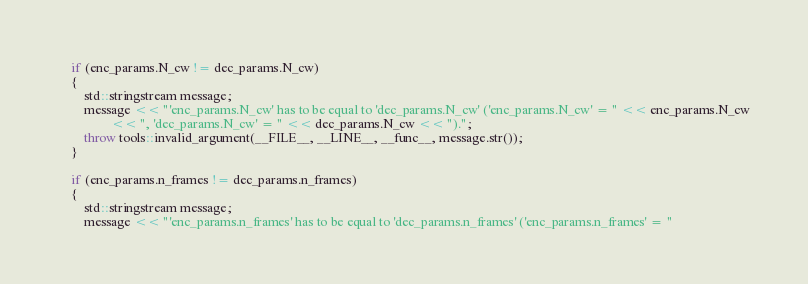<code> <loc_0><loc_0><loc_500><loc_500><_C++_>
	if (enc_params.N_cw != dec_params.N_cw)
	{
		std::stringstream message;
		message << "'enc_params.N_cw' has to be equal to 'dec_params.N_cw' ('enc_params.N_cw' = " << enc_params.N_cw
		        << ", 'dec_params.N_cw' = " << dec_params.N_cw << ").";
		throw tools::invalid_argument(__FILE__, __LINE__, __func__, message.str());
	}

	if (enc_params.n_frames != dec_params.n_frames)
	{
		std::stringstream message;
		message << "'enc_params.n_frames' has to be equal to 'dec_params.n_frames' ('enc_params.n_frames' = "</code> 